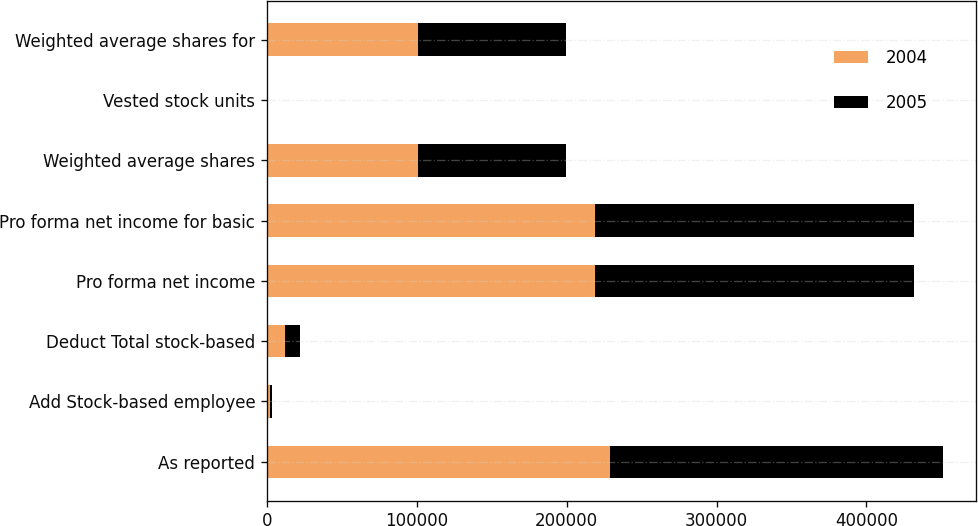<chart> <loc_0><loc_0><loc_500><loc_500><stacked_bar_chart><ecel><fcel>As reported<fcel>Add Stock-based employee<fcel>Deduct Total stock-based<fcel>Pro forma net income<fcel>Pro forma net income for basic<fcel>Weighted average shares<fcel>Vested stock units<fcel>Weighted average shares for<nl><fcel>2004<fcel>228643<fcel>2112<fcel>12180<fcel>218575<fcel>218575<fcel>100713<fcel>49<fcel>100762<nl><fcel>2005<fcel>222254<fcel>1168<fcel>10109<fcel>213313<fcel>213313<fcel>98694<fcel>33<fcel>98727<nl></chart> 